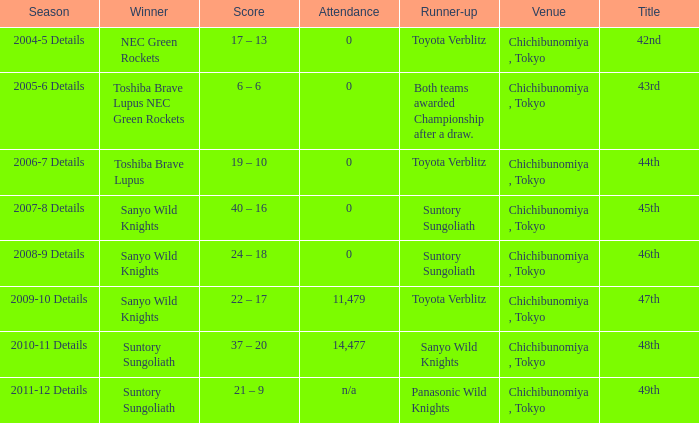What is the Score when the winner was sanyo wild knights, and a Runner-up of suntory sungoliath? 40 – 16, 24 – 18. 